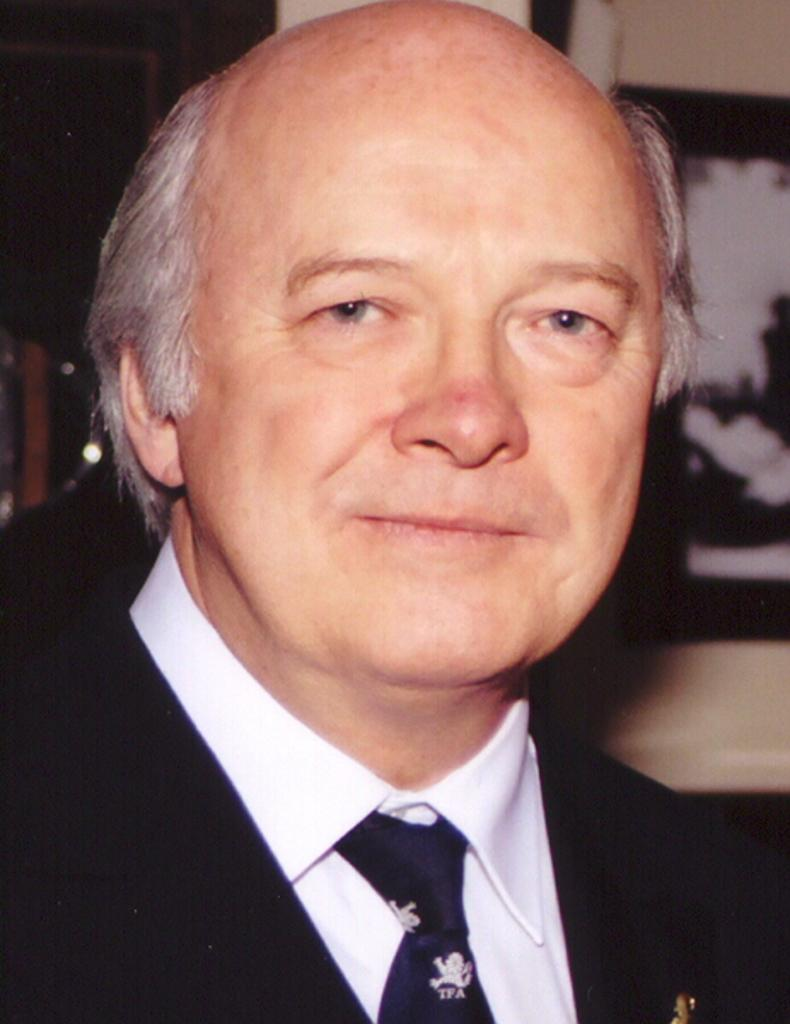Who or what is the main subject in the image? There is a person in the center of the image. Can you describe the person's attire? The person is wearing a coat and a tie. What can be seen in the background of the image? There is a wall and a frame visible in the background. How many trees are visible in the image? There are no trees visible in the image. 